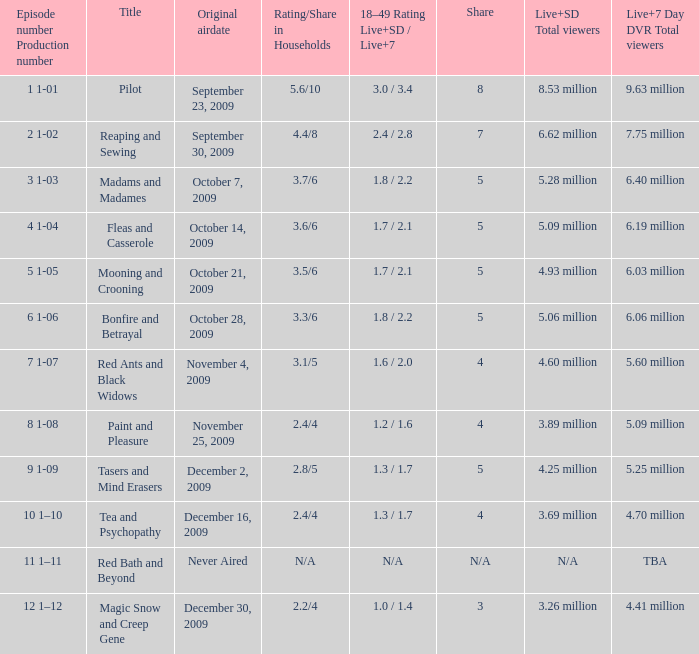What are the "18–49 Rating Live+SD" ratings and "Live+7" ratings, respectively, for the episode that originally aired on October 14, 2009? 1.7 / 2.1. 